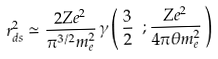Convert formula to latex. <formula><loc_0><loc_0><loc_500><loc_500>r _ { d s } ^ { 2 } \simeq \frac { 2 Z e ^ { 2 } } { \pi ^ { 3 / 2 } m ^ { 2 } _ { e } } \, \gamma \left ( \, \frac { 3 } { 2 } \ ; \frac { Z e ^ { 2 } } { 4 \pi \theta m ^ { 2 } _ { e } } \, \right )</formula> 